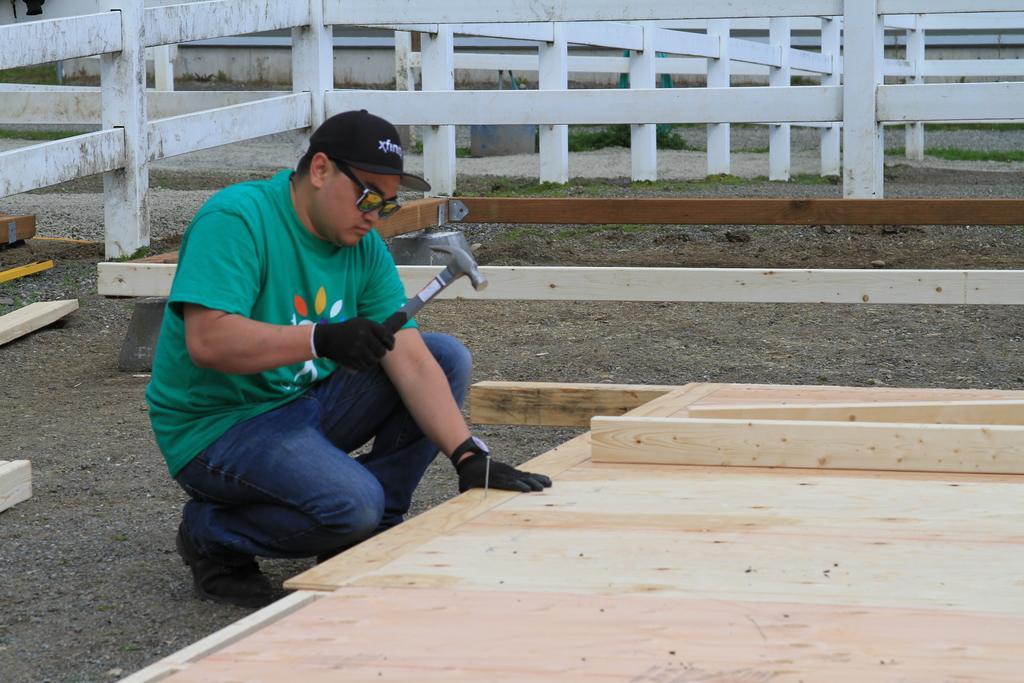What is the man in the image doing? The man is sitting in the image. What object is the man holding? The man is holding a hammer. What type of furniture can be seen in the image? There is a wooden seat in the image. What can be seen in the background of the image? Fencing is visible in the background of the image. Can you see a snake slithering through the quicksand in the image? There is no snake or quicksand present in the image. What type of stick is the man using to hit the wooden seat in the image? The man is not using a stick in the image; he is holding a hammer. 